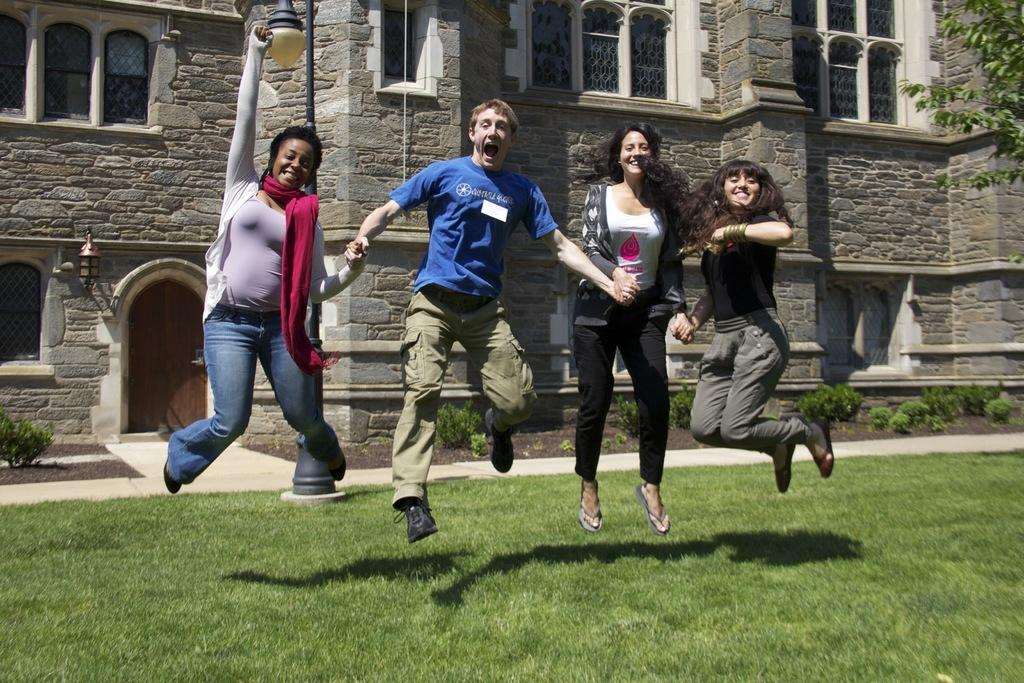How many people are present in the image? There are two people, a man and a woman, present in the image. What are the man and woman doing in the image? Both the man and woman are jumping in the image. What can be seen in the background of the image? There is a building, a tree, and a light pole in the background of the image. What is at the bottom of the image? There is grass at the bottom of the image. How many clover leaves can be seen in the image? There is no clover present in the image, so it is not possible to determine the number of clover leaves. What type of pizzas are the lizards eating in the image? There are no lizards or pizzas present in the image. 